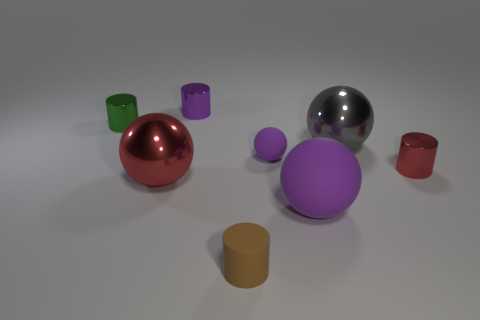What is the size of the shiny thing that is the same color as the tiny ball?
Provide a succinct answer. Small. There is a large thing that is on the left side of the brown rubber thing; what color is it?
Your answer should be compact. Red. There is a big red shiny object; is it the same shape as the gray object behind the red metallic sphere?
Keep it short and to the point. Yes. Are there any tiny matte things that have the same color as the tiny sphere?
Provide a short and direct response. No. There is a green cylinder that is the same material as the gray thing; what is its size?
Make the answer very short. Small. Is the color of the large matte thing the same as the tiny sphere?
Offer a terse response. Yes. There is a red object left of the brown matte cylinder; is it the same shape as the large gray metallic object?
Your answer should be very brief. Yes. What number of shiny objects have the same size as the gray sphere?
Your answer should be very brief. 1. The small object that is the same color as the small sphere is what shape?
Provide a succinct answer. Cylinder. There is a tiny red thing behind the tiny rubber cylinder; are there any large red metallic things on the left side of it?
Your response must be concise. Yes. 